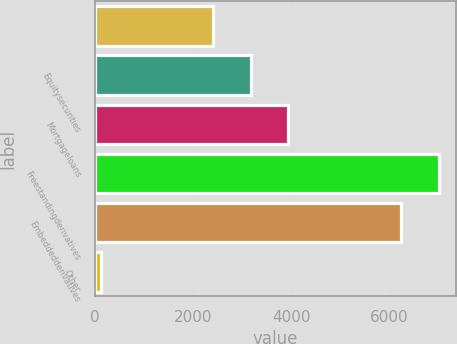<chart> <loc_0><loc_0><loc_500><loc_500><bar_chart><ecel><fcel>Equitysecurities<fcel>Mortgageloans<fcel>Freestandingderivatives<fcel>Embeddedderivatives<fcel>Other<nl><fcel>2414.2<fcel>3179.6<fcel>3945<fcel>7006.6<fcel>6241.2<fcel>118<nl></chart> 